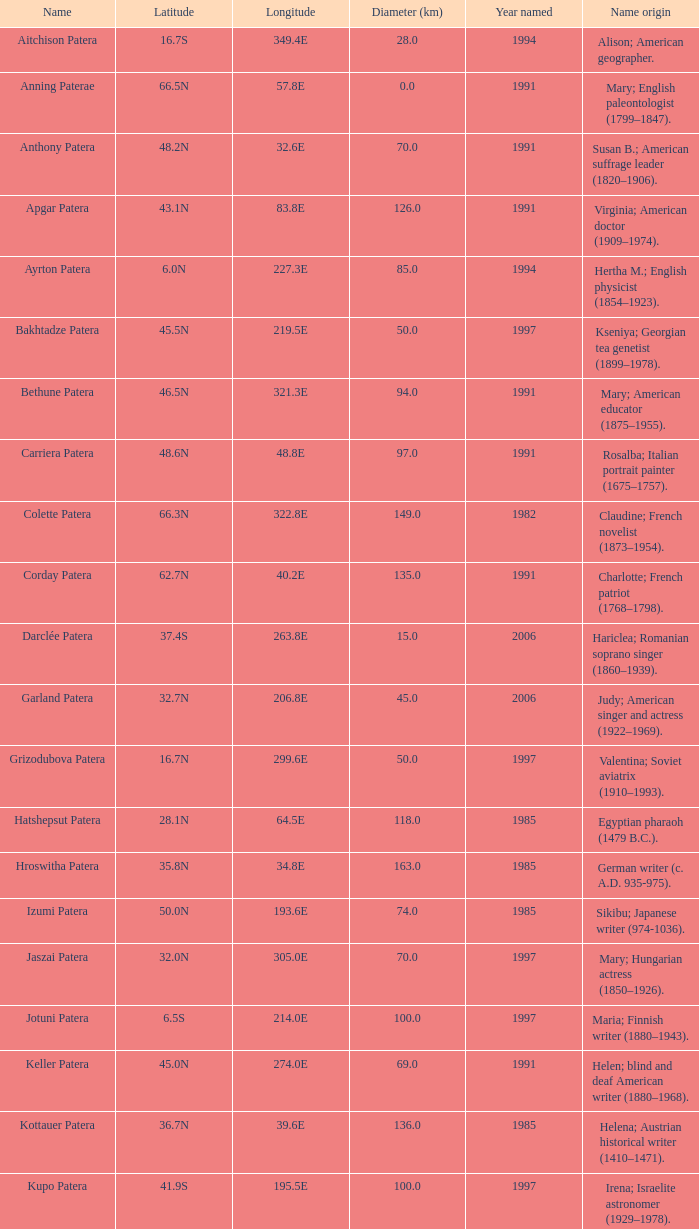How many kilometers is the diameter of the feature with a longitude of 40.2e? 135.0. 